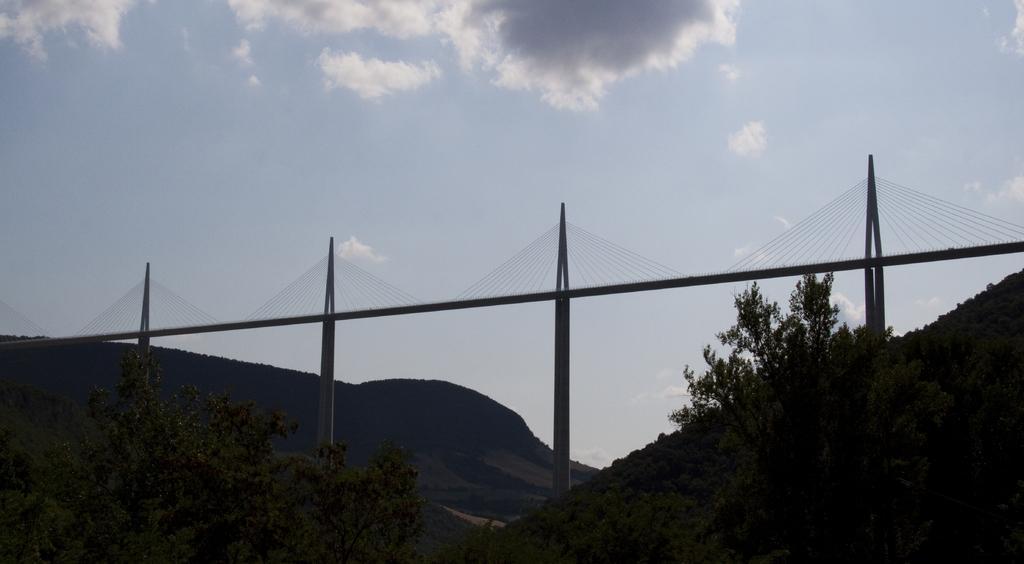How would you summarize this image in a sentence or two? In the image we can see there are trees and there is a bridge. Behind there are hills and there is a clear. There are clouds in the sky. 